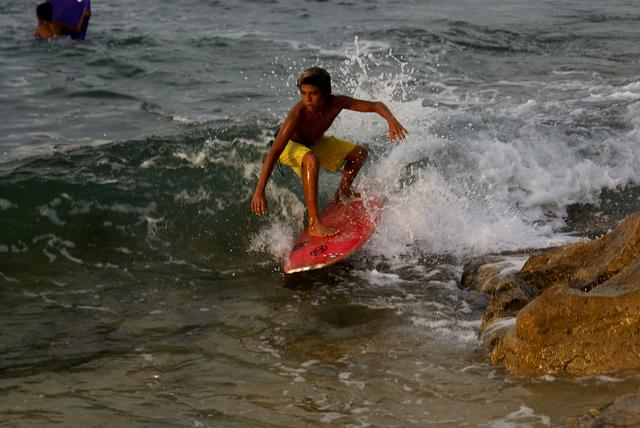What is the most obvious danger here?

Choices:
A) car accident
B) brain freeze
C) rock collision
D) shark attack rock collision 